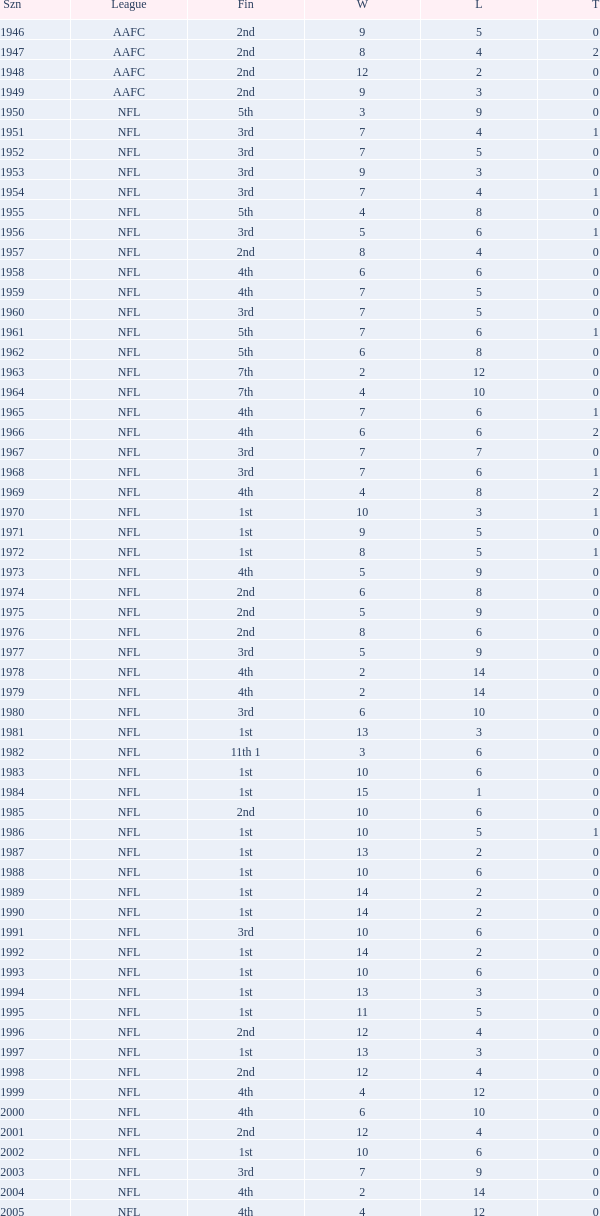What is the losses in the NFL in the 2011 season with less than 13 wins? None. Write the full table. {'header': ['Szn', 'League', 'Fin', 'W', 'L', 'T'], 'rows': [['1946', 'AAFC', '2nd', '9', '5', '0'], ['1947', 'AAFC', '2nd', '8', '4', '2'], ['1948', 'AAFC', '2nd', '12', '2', '0'], ['1949', 'AAFC', '2nd', '9', '3', '0'], ['1950', 'NFL', '5th', '3', '9', '0'], ['1951', 'NFL', '3rd', '7', '4', '1'], ['1952', 'NFL', '3rd', '7', '5', '0'], ['1953', 'NFL', '3rd', '9', '3', '0'], ['1954', 'NFL', '3rd', '7', '4', '1'], ['1955', 'NFL', '5th', '4', '8', '0'], ['1956', 'NFL', '3rd', '5', '6', '1'], ['1957', 'NFL', '2nd', '8', '4', '0'], ['1958', 'NFL', '4th', '6', '6', '0'], ['1959', 'NFL', '4th', '7', '5', '0'], ['1960', 'NFL', '3rd', '7', '5', '0'], ['1961', 'NFL', '5th', '7', '6', '1'], ['1962', 'NFL', '5th', '6', '8', '0'], ['1963', 'NFL', '7th', '2', '12', '0'], ['1964', 'NFL', '7th', '4', '10', '0'], ['1965', 'NFL', '4th', '7', '6', '1'], ['1966', 'NFL', '4th', '6', '6', '2'], ['1967', 'NFL', '3rd', '7', '7', '0'], ['1968', 'NFL', '3rd', '7', '6', '1'], ['1969', 'NFL', '4th', '4', '8', '2'], ['1970', 'NFL', '1st', '10', '3', '1'], ['1971', 'NFL', '1st', '9', '5', '0'], ['1972', 'NFL', '1st', '8', '5', '1'], ['1973', 'NFL', '4th', '5', '9', '0'], ['1974', 'NFL', '2nd', '6', '8', '0'], ['1975', 'NFL', '2nd', '5', '9', '0'], ['1976', 'NFL', '2nd', '8', '6', '0'], ['1977', 'NFL', '3rd', '5', '9', '0'], ['1978', 'NFL', '4th', '2', '14', '0'], ['1979', 'NFL', '4th', '2', '14', '0'], ['1980', 'NFL', '3rd', '6', '10', '0'], ['1981', 'NFL', '1st', '13', '3', '0'], ['1982', 'NFL', '11th 1', '3', '6', '0'], ['1983', 'NFL', '1st', '10', '6', '0'], ['1984', 'NFL', '1st', '15', '1', '0'], ['1985', 'NFL', '2nd', '10', '6', '0'], ['1986', 'NFL', '1st', '10', '5', '1'], ['1987', 'NFL', '1st', '13', '2', '0'], ['1988', 'NFL', '1st', '10', '6', '0'], ['1989', 'NFL', '1st', '14', '2', '0'], ['1990', 'NFL', '1st', '14', '2', '0'], ['1991', 'NFL', '3rd', '10', '6', '0'], ['1992', 'NFL', '1st', '14', '2', '0'], ['1993', 'NFL', '1st', '10', '6', '0'], ['1994', 'NFL', '1st', '13', '3', '0'], ['1995', 'NFL', '1st', '11', '5', '0'], ['1996', 'NFL', '2nd', '12', '4', '0'], ['1997', 'NFL', '1st', '13', '3', '0'], ['1998', 'NFL', '2nd', '12', '4', '0'], ['1999', 'NFL', '4th', '4', '12', '0'], ['2000', 'NFL', '4th', '6', '10', '0'], ['2001', 'NFL', '2nd', '12', '4', '0'], ['2002', 'NFL', '1st', '10', '6', '0'], ['2003', 'NFL', '3rd', '7', '9', '0'], ['2004', 'NFL', '4th', '2', '14', '0'], ['2005', 'NFL', '4th', '4', '12', '0'], ['2006', 'NFL', '3rd', '7', '9', '0'], ['2007', 'NFL', '3rd', '5', '11', '0'], ['2008', 'NFL', '2nd', '7', '9', '0'], ['2009', 'NFL', '2nd', '8', '8', '0'], ['2010', 'NFL', '3rd', '6', '10', '0'], ['2011', 'NFL', '1st', '13', '3', '0'], ['2012', 'NFL', '1st', '11', '4', '1'], ['2013', 'NFL', '2nd', '6', '2', '0']]} 